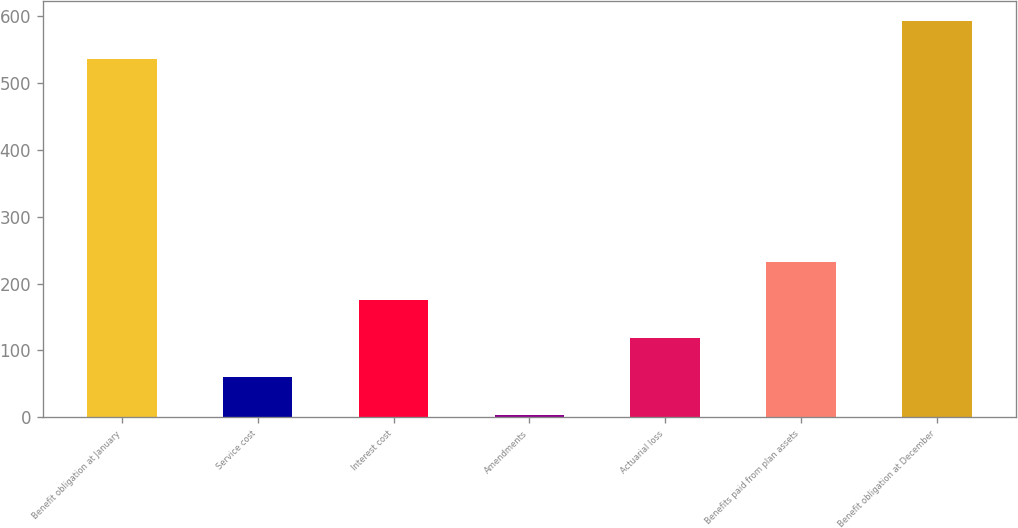<chart> <loc_0><loc_0><loc_500><loc_500><bar_chart><fcel>Benefit obligation at January<fcel>Service cost<fcel>Interest cost<fcel>Amendments<fcel>Actuarial loss<fcel>Benefits paid from plan assets<fcel>Benefit obligation at December<nl><fcel>535.9<fcel>60.95<fcel>175.25<fcel>3.8<fcel>118.1<fcel>232.4<fcel>593.05<nl></chart> 